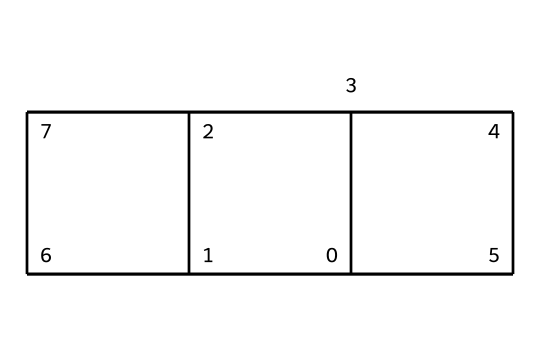What is the molecular formula of cubane? The molecular formula can be determined by counting the number of carbon (C) and hydrogen (H) atoms present in the structure. In cubane, there are 8 carbon atoms and 8 hydrogen atoms. Therefore, the molecular formula is C8H8.
Answer: C8H8 How many carbon atoms are present in cubane? By examining the structure, you can see that there are 8 vertices corresponding to carbon atoms. Thus, there are 8 carbon atoms in total.
Answer: 8 What shapes or forms can be associated with the symmetry of cubane? Cubane has a symmetrical structure that can be visualized as a cube. Each face of the cube contains a carbon atom, contributing to its cubic symmetry.
Answer: cube What type of compound is cubane? Cubane is classified as a hydrocarbon because it is composed entirely of hydrogen and carbon atoms.
Answer: hydrocarbon Which feature of cubane contributes to its unique structural stability? The unusual feature contributing to cubane's stability is its highly strained cubic structure, resulting in a conformation with significant angle strain compared to typical hydrocarbons.
Answer: angle strain How many hydrogen atoms are bonded to each carbon in cubane? Each of the 8 carbon atoms in cubane is bonded to 2 hydrogen atoms, as they are arranged to maintain stability despite bond strain.
Answer: 2 What is the significance of the cage-like structure in cubane compared to other hydrocarbons? The cage-like structure of cubane allows for unique chemical properties and reactivity, distinguishing it from linear or branched hydrocarbons; this structure enables potential applications in materials science and organic synthesis.
Answer: unique properties 